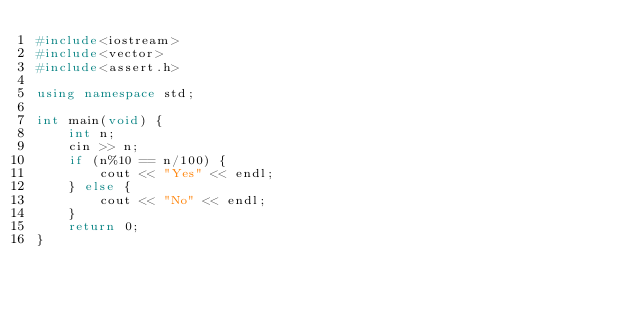<code> <loc_0><loc_0><loc_500><loc_500><_C++_>#include<iostream>
#include<vector>
#include<assert.h>

using namespace std;

int main(void) {
    int n;
    cin >> n;
    if (n%10 == n/100) {
        cout << "Yes" << endl;
    } else {
        cout << "No" << endl;
    }
    return 0;
}
</code> 